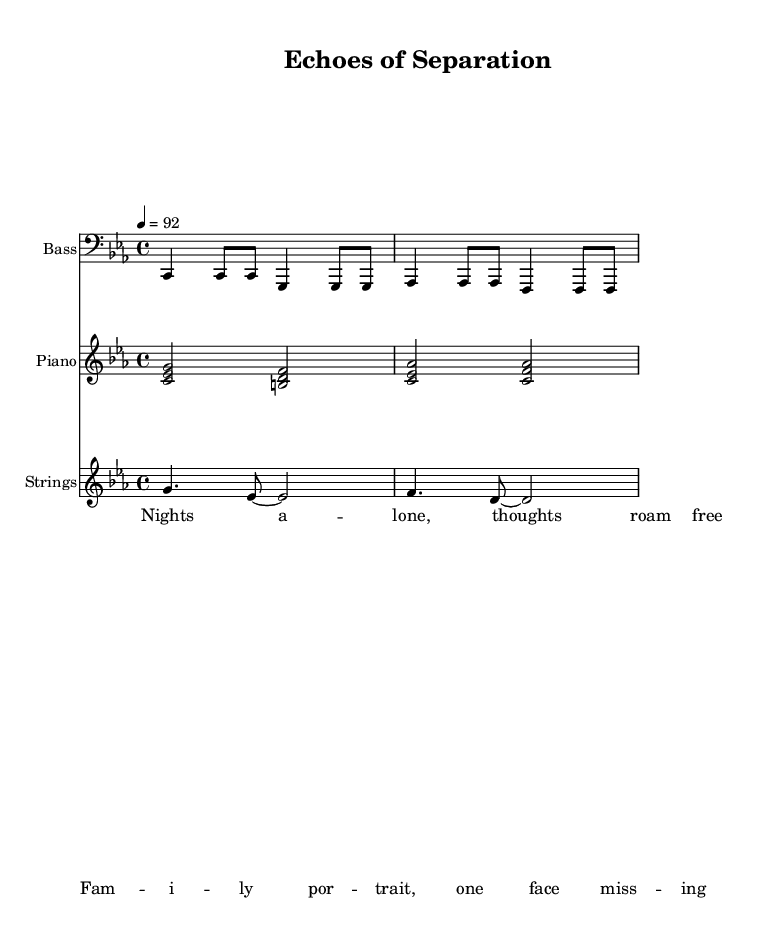What is the key signature of this music? The key signature is C minor, which has three flats: B flat, E flat, and A flat. This indicates that the piece is based in a minor tonality.
Answer: C minor What is the time signature of this piece? The time signature is 4/4, meaning there are four beats in each measure, and the quarter note gets one beat. This is a common time signature used in many music genres, including rap.
Answer: 4/4 What is the tempo of the piece? The tempo is marked at 92 beats per minute, indicating a moderate pace. This gives the music a reflective yet steady rhythmic feel, suitable for conveying emotional themes.
Answer: 92 What is the primary emotion expressed in the lyrics? The lyrics suggest feelings of loneliness and missing a loved one, which relates to the emotional impact of deployment on military families. The mention of having a “face missing” emphasizes this disconnect during separation.
Answer: Loneliness Which instruments are included in this score? The score includes bass, piano, and strings, making use of each to create a rich harmonic and melodic texture common in rap music arrangements.
Answer: Bass, piano, strings What do the lyrics indicate about the themes of the song? The lyrics stress the theme of emotional struggle associated with separation from family during deployment, highlighting the essence of a military family's sacrifice during such times.
Answer: Emotional struggle 